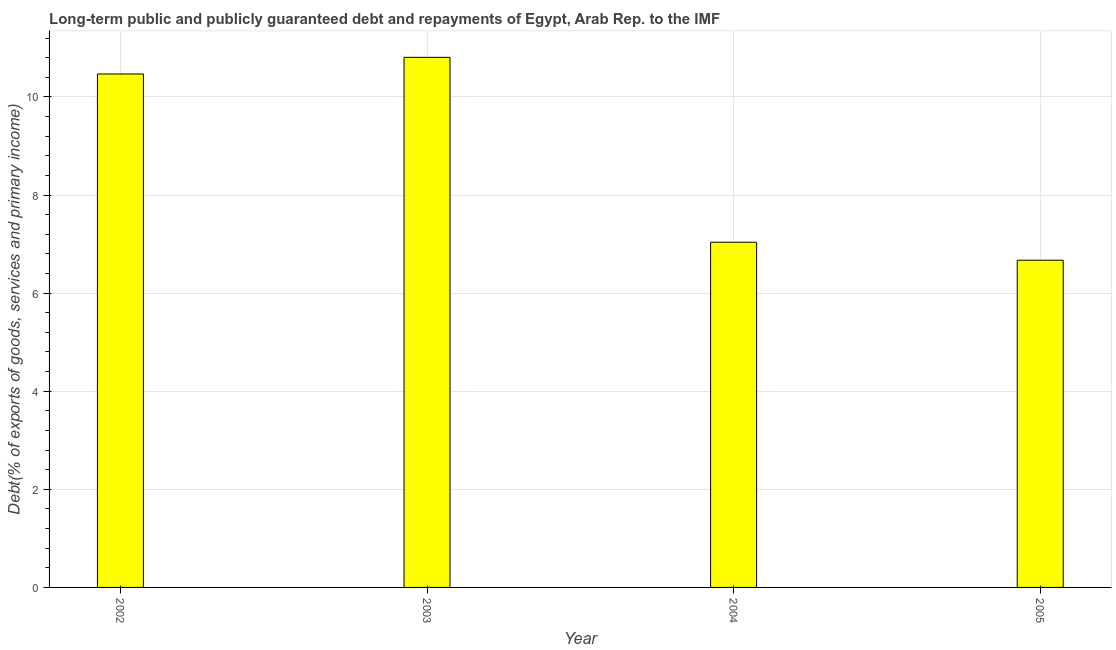Does the graph contain grids?
Keep it short and to the point. Yes. What is the title of the graph?
Your answer should be very brief. Long-term public and publicly guaranteed debt and repayments of Egypt, Arab Rep. to the IMF. What is the label or title of the Y-axis?
Provide a succinct answer. Debt(% of exports of goods, services and primary income). What is the debt service in 2004?
Give a very brief answer. 7.04. Across all years, what is the maximum debt service?
Provide a short and direct response. 10.81. Across all years, what is the minimum debt service?
Provide a short and direct response. 6.67. In which year was the debt service maximum?
Offer a terse response. 2003. In which year was the debt service minimum?
Offer a terse response. 2005. What is the sum of the debt service?
Give a very brief answer. 34.98. What is the difference between the debt service in 2003 and 2005?
Keep it short and to the point. 4.14. What is the average debt service per year?
Your answer should be compact. 8.75. What is the median debt service?
Provide a succinct answer. 8.75. In how many years, is the debt service greater than 5.6 %?
Your response must be concise. 4. Do a majority of the years between 2003 and 2005 (inclusive) have debt service greater than 2.8 %?
Provide a short and direct response. Yes. What is the ratio of the debt service in 2002 to that in 2004?
Your response must be concise. 1.49. Is the debt service in 2002 less than that in 2005?
Keep it short and to the point. No. What is the difference between the highest and the second highest debt service?
Keep it short and to the point. 0.34. Is the sum of the debt service in 2003 and 2004 greater than the maximum debt service across all years?
Your response must be concise. Yes. What is the difference between the highest and the lowest debt service?
Your answer should be compact. 4.14. In how many years, is the debt service greater than the average debt service taken over all years?
Provide a succinct answer. 2. How many years are there in the graph?
Give a very brief answer. 4. What is the difference between two consecutive major ticks on the Y-axis?
Ensure brevity in your answer.  2. Are the values on the major ticks of Y-axis written in scientific E-notation?
Your answer should be compact. No. What is the Debt(% of exports of goods, services and primary income) of 2002?
Ensure brevity in your answer.  10.47. What is the Debt(% of exports of goods, services and primary income) in 2003?
Provide a short and direct response. 10.81. What is the Debt(% of exports of goods, services and primary income) of 2004?
Provide a short and direct response. 7.04. What is the Debt(% of exports of goods, services and primary income) in 2005?
Your answer should be very brief. 6.67. What is the difference between the Debt(% of exports of goods, services and primary income) in 2002 and 2003?
Your response must be concise. -0.34. What is the difference between the Debt(% of exports of goods, services and primary income) in 2002 and 2004?
Your response must be concise. 3.43. What is the difference between the Debt(% of exports of goods, services and primary income) in 2002 and 2005?
Provide a short and direct response. 3.8. What is the difference between the Debt(% of exports of goods, services and primary income) in 2003 and 2004?
Offer a very short reply. 3.77. What is the difference between the Debt(% of exports of goods, services and primary income) in 2003 and 2005?
Offer a terse response. 4.14. What is the difference between the Debt(% of exports of goods, services and primary income) in 2004 and 2005?
Provide a succinct answer. 0.37. What is the ratio of the Debt(% of exports of goods, services and primary income) in 2002 to that in 2004?
Keep it short and to the point. 1.49. What is the ratio of the Debt(% of exports of goods, services and primary income) in 2002 to that in 2005?
Your answer should be compact. 1.57. What is the ratio of the Debt(% of exports of goods, services and primary income) in 2003 to that in 2004?
Ensure brevity in your answer.  1.54. What is the ratio of the Debt(% of exports of goods, services and primary income) in 2003 to that in 2005?
Your answer should be compact. 1.62. What is the ratio of the Debt(% of exports of goods, services and primary income) in 2004 to that in 2005?
Offer a very short reply. 1.05. 